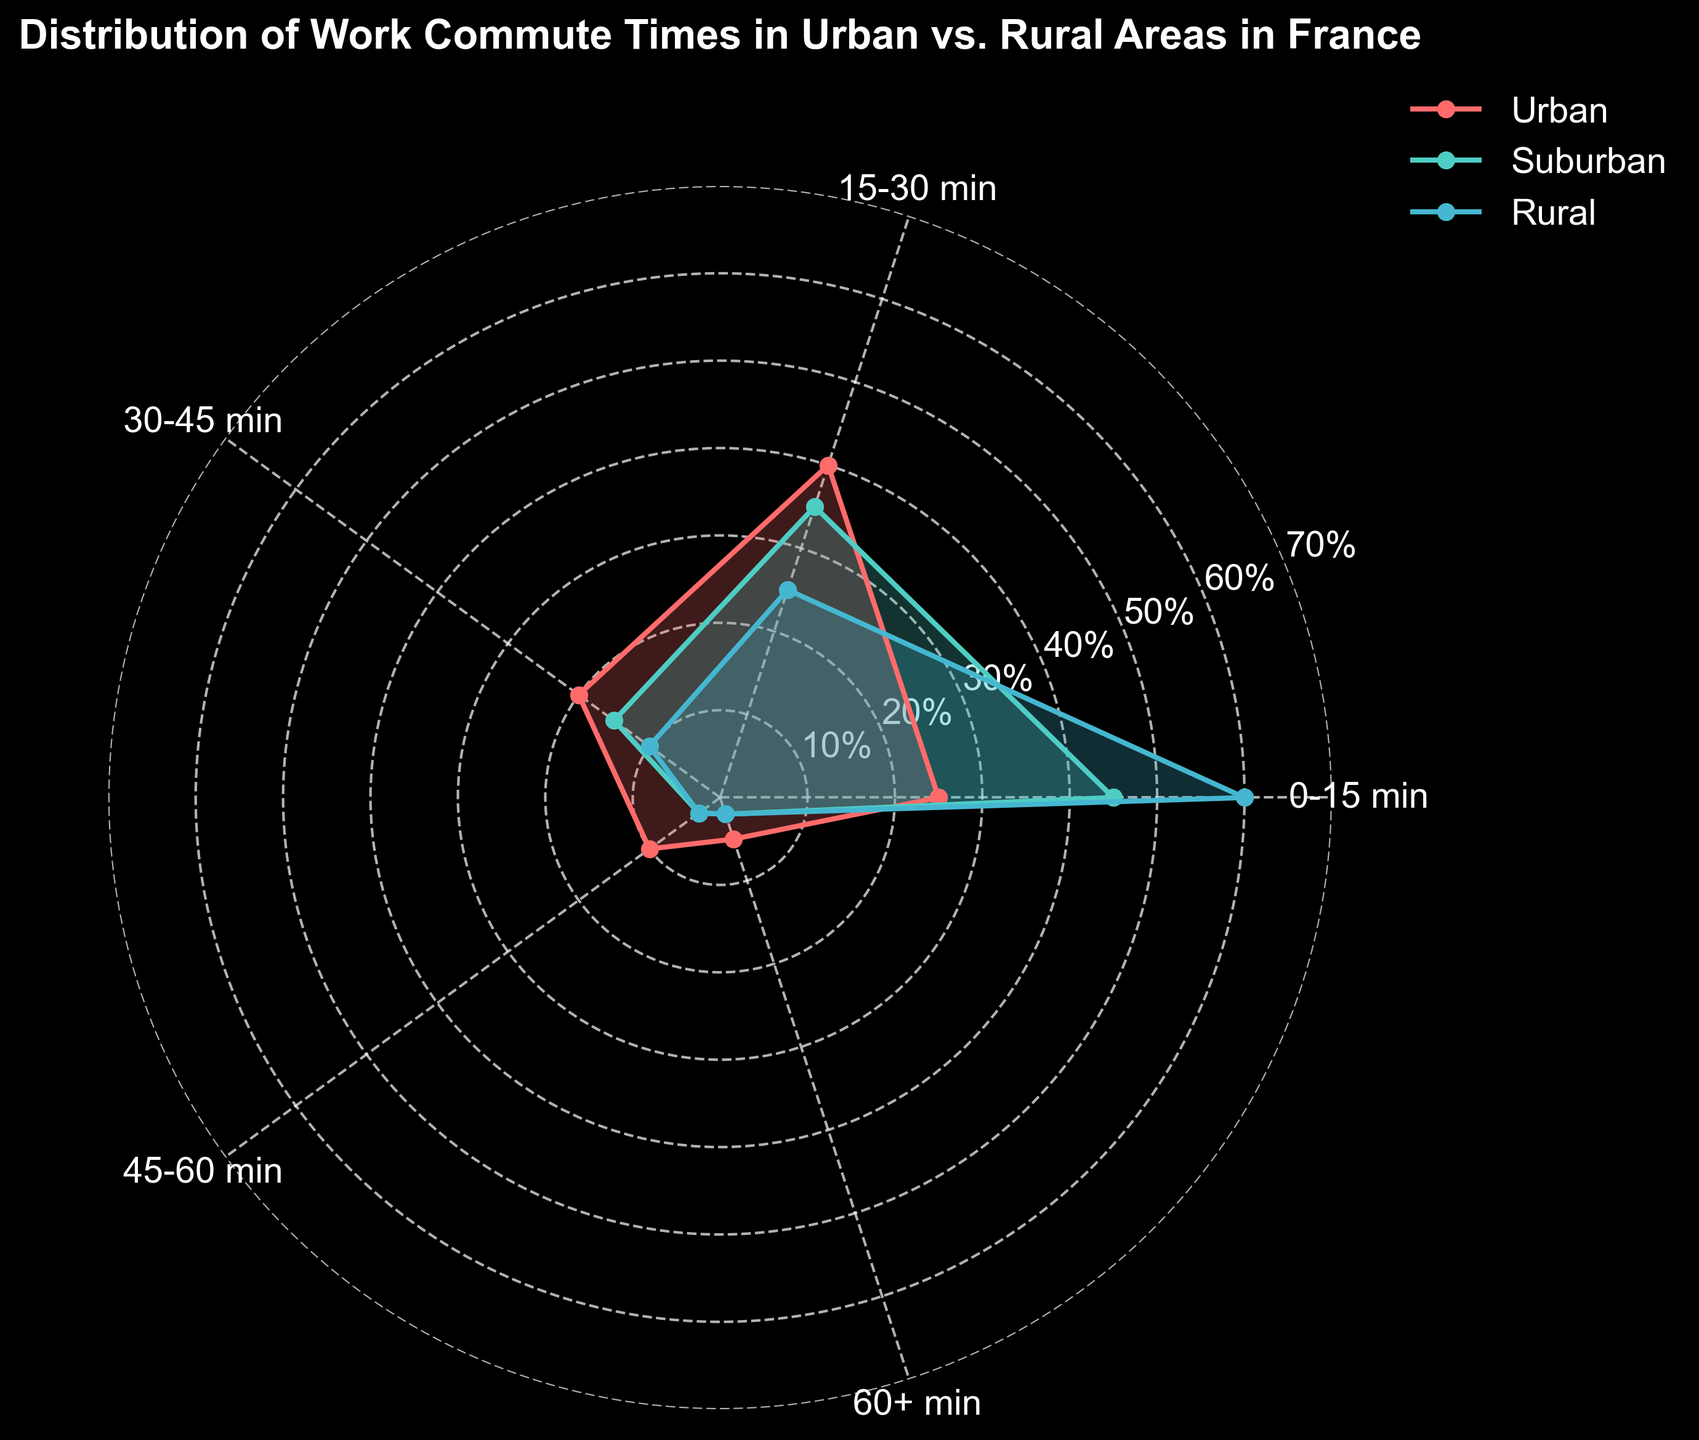What's the title of the figure? The title is usually located at the top of the figure. In this case, it indicates what the chart is about.
Answer: Distribution of Work Commute Times in Urban vs. Rural Areas in France Which area has the highest percentage of commutes that are 0-15 minutes? To determine this, look at the values for the 0-15 min category and compare them across Urban, Suburban, and Rural areas.
Answer: Rural What is the percentage of people with commutes between 15-30 minutes in suburban areas? Find the 15-30 minute category and check its value for the suburban area.
Answer: 35% For which time category does the urban area have a higher percentage than suburban and rural areas? Check each time category and compare the percentages for urban, suburban, and rural areas to find where urban has the highest value.
Answer: 15-30 min What is the difference in the percentage of people with 0-15 minute commutes between urban and suburban areas? Subtract the urban percentage from the suburban percentage for the 0-15 minute category: 45% - 25% = 20%.
Answer: 20% Which area has the lowest percentage of commutes lasting 45-60 minutes? Compare the percentages for the 45-60 minute category across all three areas.
Answer: Suburban How does the percentage of 30-45 minute commutes in rural areas compare to that in urban areas? Compare the percentages for the 30-45 minute category between rural and urban areas.
Answer: Rural has a lower percentage What percentage of people have commutes longer than 60 minutes in rural areas? Look at the value in the 60+ minute category for the rural area.
Answer: 2% In which time category do urban and suburban areas have equal percentages? Find the time category where both urban and suburban areas have the same percentage.
Answer: 45-60 min How does the distribution shape differ between urban and rural areas? Compare the filled areas of the urban and rural plots to observe differences in the distribution shapes.
Answer: Urban has more concentration in the 15-30 min category, Rural in 0-15 min 